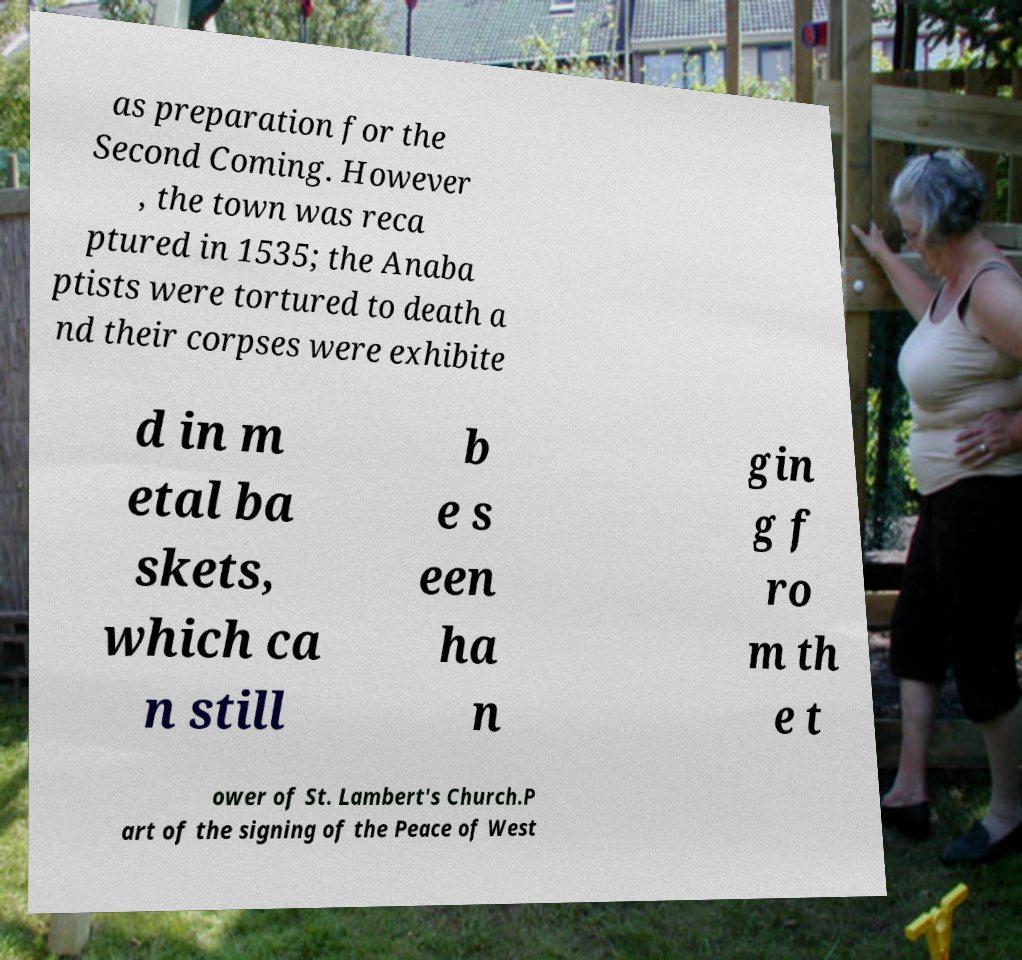I need the written content from this picture converted into text. Can you do that? as preparation for the Second Coming. However , the town was reca ptured in 1535; the Anaba ptists were tortured to death a nd their corpses were exhibite d in m etal ba skets, which ca n still b e s een ha n gin g f ro m th e t ower of St. Lambert's Church.P art of the signing of the Peace of West 